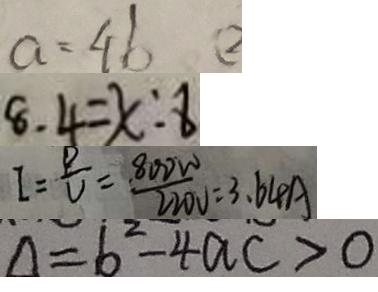Convert formula to latex. <formula><loc_0><loc_0><loc_500><loc_500>a = 4 b ( 2 
 8 . 4 = x : 8 
 I = \frac { P } { U } = \frac { 8 0 0 W } { 2 2 0 V } = 3 . 6 4 A 
 \Delta = 6 ^ { 2 } - 4 a c > 0</formula> 